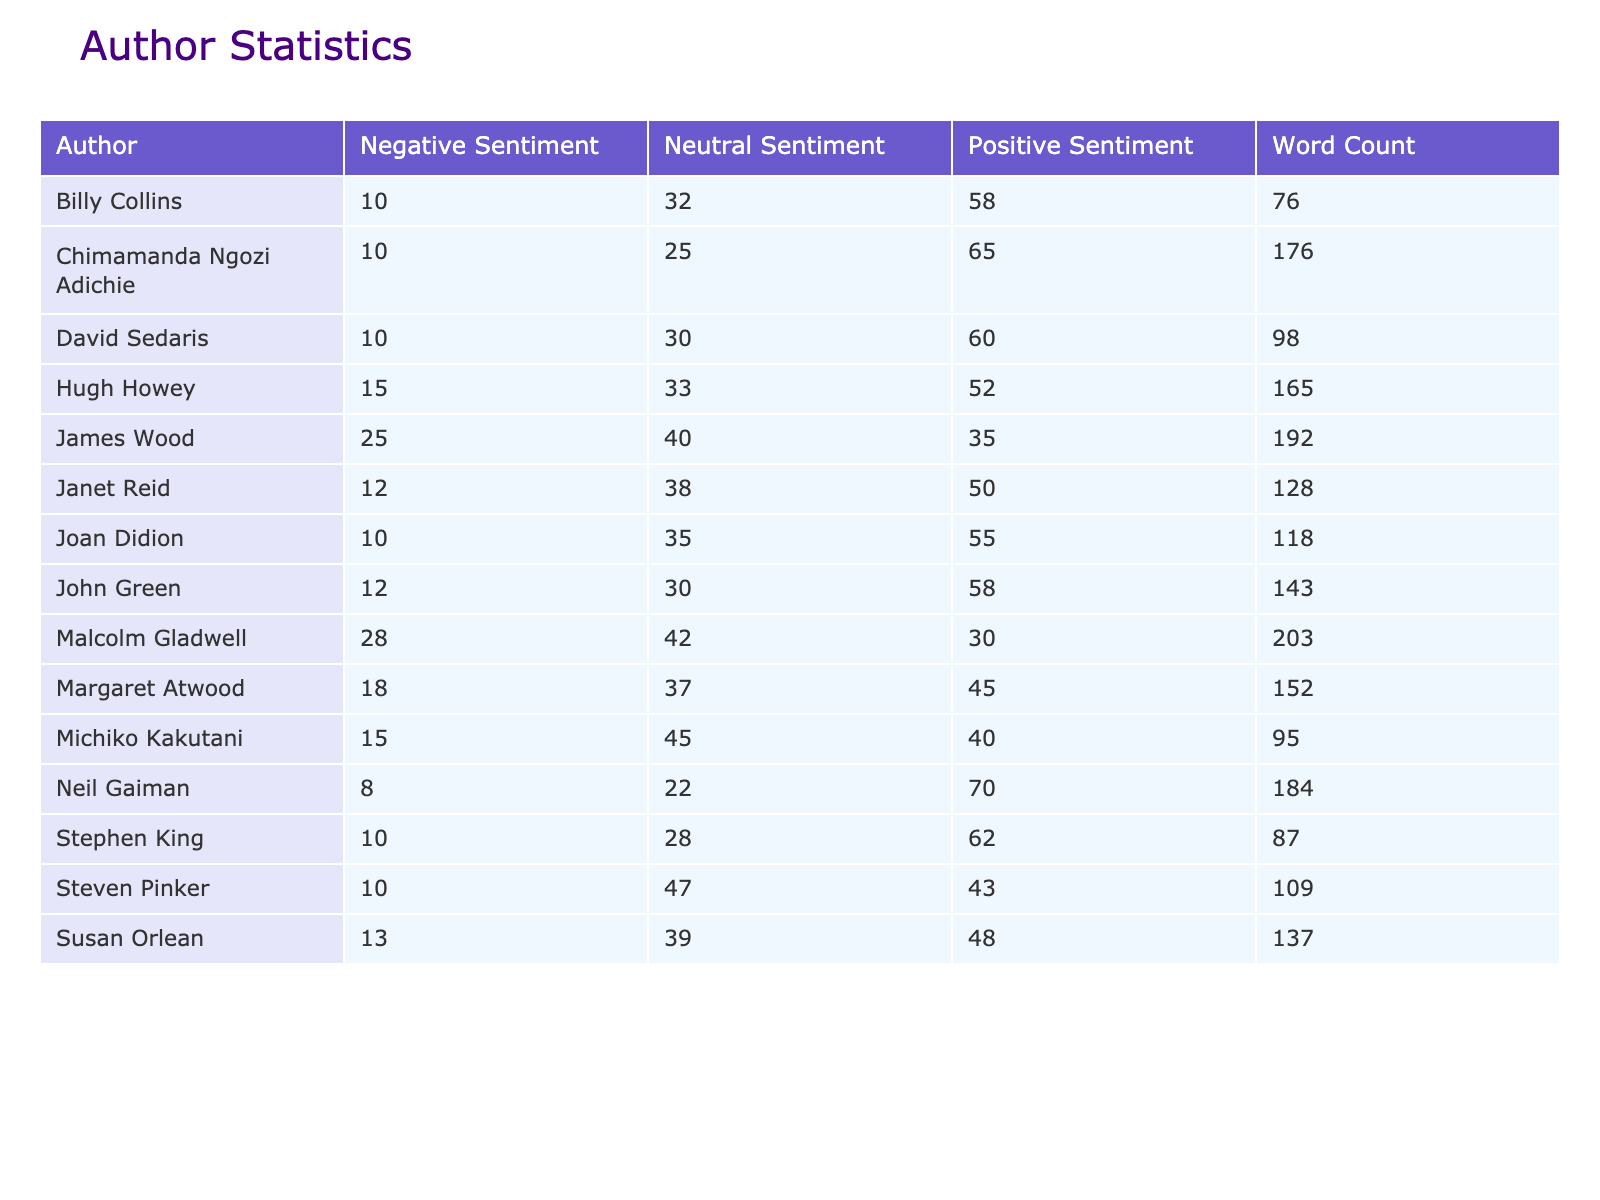What is the word count for "The Art of Book Reviews"? The table lists the word count for each article under the "Word Count" column. By finding the row for "The Art of Book Reviews," we can see that the word count is 95.
Answer: 95 Which author has the highest positive sentiment? To determine the author with the highest positive sentiment, we can compare the values in the "Positive Sentiment" column. The highest value is 70, which corresponds to Neil Gaiman.
Answer: Neil Gaiman What is the average negative sentiment across all articles? We sum the negative sentiments from all authors: (18 + 10 + 28 + 10 + 15 + 10 + 8 + 13 + 15 + 10 + 25 + 12 + 10 + 12) =  19. The total number of articles is 14. To find the average, we divide the total negative sentiment by 14:  19/14 = 1.35.
Answer: 1.35 Is the total comments for "The Importance of Diverse Voices in Literature" equal to 100? The table states that the total comments for every article is consistently listed as 100, including "The Importance of Diverse Voices in Literature." Therefore, the statement is true.
Answer: Yes How many authors have a word count below 100? We need to count the authors whose word count is less than 100. By checking each row, we find the authors "How to Craft Compelling Characters", "Poetry in the Digital Age", "The Art of the Personal Essay", and "The Art of Book Reviews", totaling 4 authors.
Answer: 4 